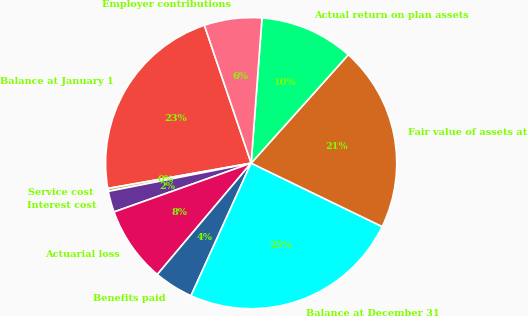Convert chart to OTSL. <chart><loc_0><loc_0><loc_500><loc_500><pie_chart><fcel>Balance at January 1<fcel>Service cost<fcel>Interest cost<fcel>Actuarial loss<fcel>Benefits paid<fcel>Balance at December 31<fcel>Fair value of assets at<fcel>Actual return on plan assets<fcel>Employer contributions<nl><fcel>22.58%<fcel>0.32%<fcel>2.34%<fcel>8.41%<fcel>4.37%<fcel>24.6%<fcel>20.55%<fcel>10.44%<fcel>6.39%<nl></chart> 